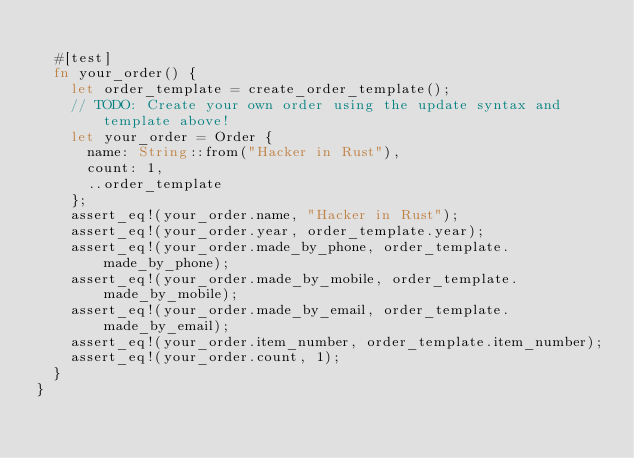Convert code to text. <code><loc_0><loc_0><loc_500><loc_500><_Rust_>
  #[test]
  fn your_order() {
    let order_template = create_order_template();
    // TODO: Create your own order using the update syntax and template above!
    let your_order = Order {
      name: String::from("Hacker in Rust"),
      count: 1,
      ..order_template
    };
    assert_eq!(your_order.name, "Hacker in Rust");
    assert_eq!(your_order.year, order_template.year);
    assert_eq!(your_order.made_by_phone, order_template.made_by_phone);
    assert_eq!(your_order.made_by_mobile, order_template.made_by_mobile);
    assert_eq!(your_order.made_by_email, order_template.made_by_email);
    assert_eq!(your_order.item_number, order_template.item_number);
    assert_eq!(your_order.count, 1);
  }
}
</code> 